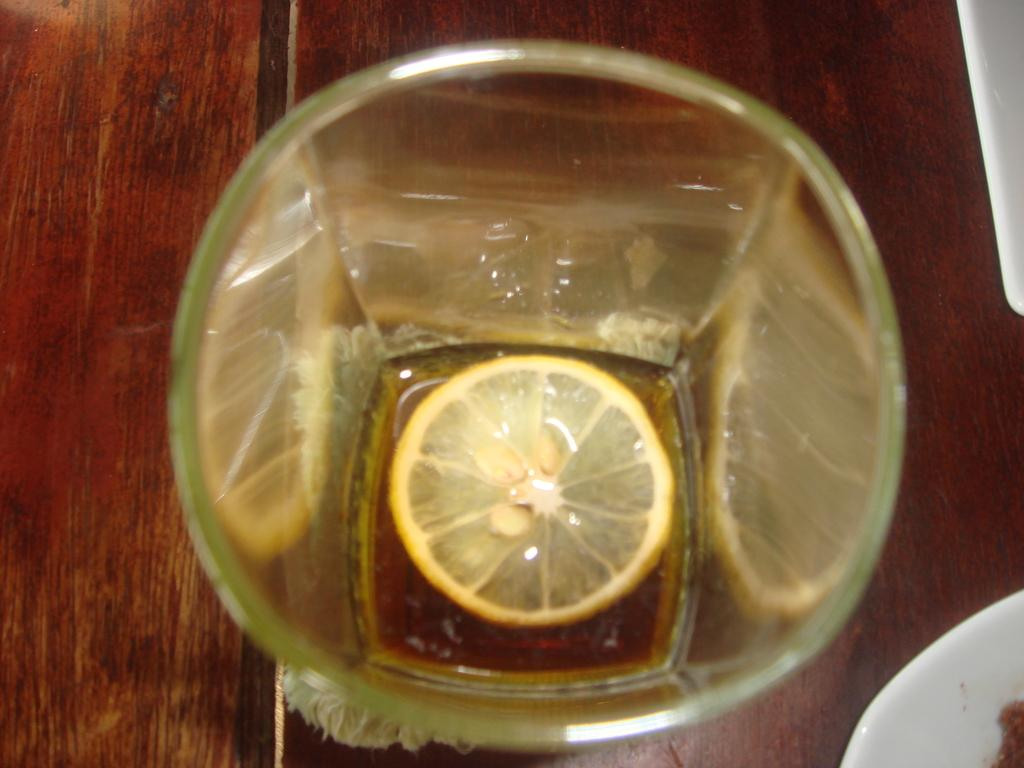What fruit is present in the image? There is a lemon in the image. How is the lemon displayed in the image? The lemon is placed in a glass. What type of surface is the glass resting on? The glass is on a wooden surface. What language is being spoken by the lemon in the image? The lemon does not speak any language in the image, as it is an inanimate object. 